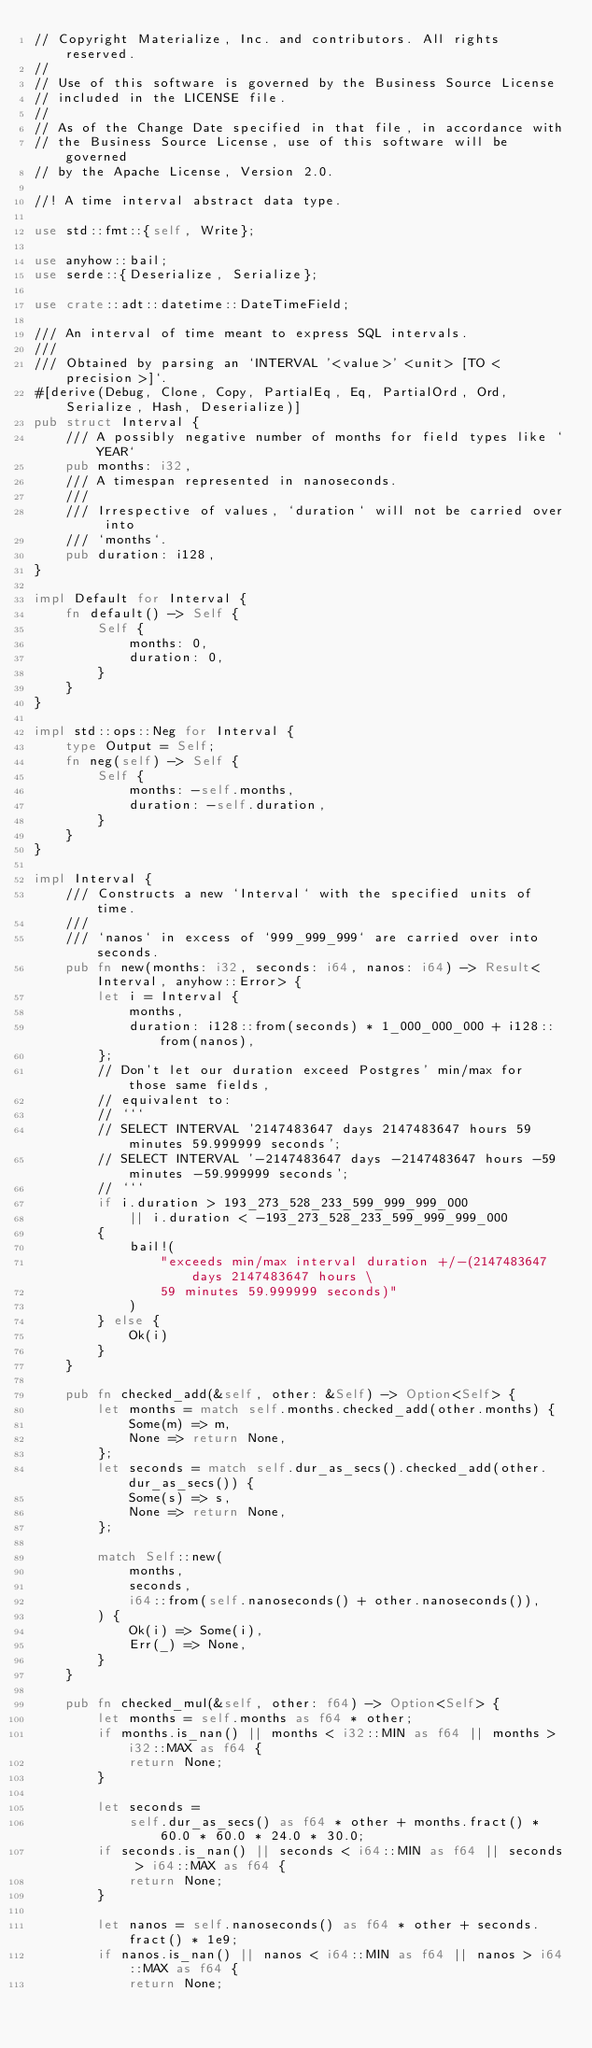<code> <loc_0><loc_0><loc_500><loc_500><_Rust_>// Copyright Materialize, Inc. and contributors. All rights reserved.
//
// Use of this software is governed by the Business Source License
// included in the LICENSE file.
//
// As of the Change Date specified in that file, in accordance with
// the Business Source License, use of this software will be governed
// by the Apache License, Version 2.0.

//! A time interval abstract data type.

use std::fmt::{self, Write};

use anyhow::bail;
use serde::{Deserialize, Serialize};

use crate::adt::datetime::DateTimeField;

/// An interval of time meant to express SQL intervals.
///
/// Obtained by parsing an `INTERVAL '<value>' <unit> [TO <precision>]`.
#[derive(Debug, Clone, Copy, PartialEq, Eq, PartialOrd, Ord, Serialize, Hash, Deserialize)]
pub struct Interval {
    /// A possibly negative number of months for field types like `YEAR`
    pub months: i32,
    /// A timespan represented in nanoseconds.
    ///
    /// Irrespective of values, `duration` will not be carried over into
    /// `months`.
    pub duration: i128,
}

impl Default for Interval {
    fn default() -> Self {
        Self {
            months: 0,
            duration: 0,
        }
    }
}

impl std::ops::Neg for Interval {
    type Output = Self;
    fn neg(self) -> Self {
        Self {
            months: -self.months,
            duration: -self.duration,
        }
    }
}

impl Interval {
    /// Constructs a new `Interval` with the specified units of time.
    ///
    /// `nanos` in excess of `999_999_999` are carried over into seconds.
    pub fn new(months: i32, seconds: i64, nanos: i64) -> Result<Interval, anyhow::Error> {
        let i = Interval {
            months,
            duration: i128::from(seconds) * 1_000_000_000 + i128::from(nanos),
        };
        // Don't let our duration exceed Postgres' min/max for those same fields,
        // equivalent to:
        // ```
        // SELECT INTERVAL '2147483647 days 2147483647 hours 59 minutes 59.999999 seconds';
        // SELECT INTERVAL '-2147483647 days -2147483647 hours -59 minutes -59.999999 seconds';
        // ```
        if i.duration > 193_273_528_233_599_999_999_000
            || i.duration < -193_273_528_233_599_999_999_000
        {
            bail!(
                "exceeds min/max interval duration +/-(2147483647 days 2147483647 hours \
                59 minutes 59.999999 seconds)"
            )
        } else {
            Ok(i)
        }
    }

    pub fn checked_add(&self, other: &Self) -> Option<Self> {
        let months = match self.months.checked_add(other.months) {
            Some(m) => m,
            None => return None,
        };
        let seconds = match self.dur_as_secs().checked_add(other.dur_as_secs()) {
            Some(s) => s,
            None => return None,
        };

        match Self::new(
            months,
            seconds,
            i64::from(self.nanoseconds() + other.nanoseconds()),
        ) {
            Ok(i) => Some(i),
            Err(_) => None,
        }
    }

    pub fn checked_mul(&self, other: f64) -> Option<Self> {
        let months = self.months as f64 * other;
        if months.is_nan() || months < i32::MIN as f64 || months > i32::MAX as f64 {
            return None;
        }

        let seconds =
            self.dur_as_secs() as f64 * other + months.fract() * 60.0 * 60.0 * 24.0 * 30.0;
        if seconds.is_nan() || seconds < i64::MIN as f64 || seconds > i64::MAX as f64 {
            return None;
        }

        let nanos = self.nanoseconds() as f64 * other + seconds.fract() * 1e9;
        if nanos.is_nan() || nanos < i64::MIN as f64 || nanos > i64::MAX as f64 {
            return None;</code> 